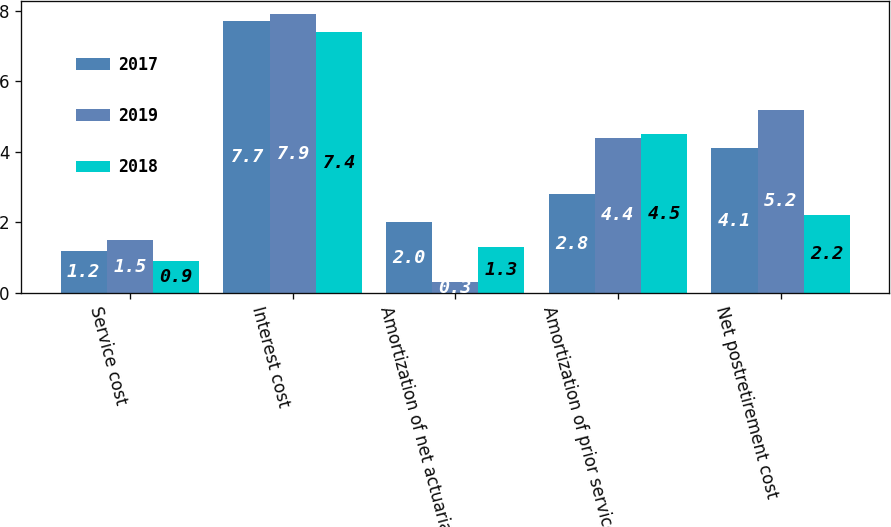Convert chart. <chart><loc_0><loc_0><loc_500><loc_500><stacked_bar_chart><ecel><fcel>Service cost<fcel>Interest cost<fcel>Amortization of net actuarial<fcel>Amortization of prior service<fcel>Net postretirement cost<nl><fcel>2017<fcel>1.2<fcel>7.7<fcel>2<fcel>2.8<fcel>4.1<nl><fcel>2019<fcel>1.5<fcel>7.9<fcel>0.3<fcel>4.4<fcel>5.2<nl><fcel>2018<fcel>0.9<fcel>7.4<fcel>1.3<fcel>4.5<fcel>2.2<nl></chart> 